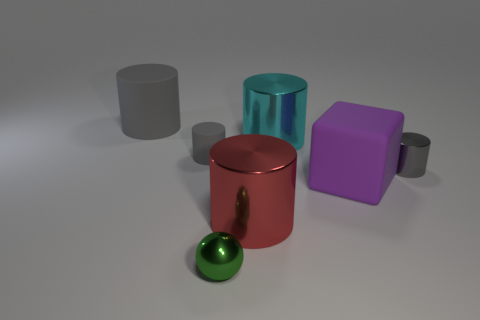Subtract all gray cylinders. How many were subtracted if there are1gray cylinders left? 2 Subtract all small matte cylinders. How many cylinders are left? 4 Subtract all gray cylinders. How many cylinders are left? 2 Add 7 red rubber objects. How many red rubber objects exist? 7 Add 1 tiny blue matte cylinders. How many objects exist? 8 Subtract 1 red cylinders. How many objects are left? 6 Subtract all cylinders. How many objects are left? 2 Subtract 1 cylinders. How many cylinders are left? 4 Subtract all purple cylinders. Subtract all brown spheres. How many cylinders are left? 5 Subtract all green balls. How many gray cylinders are left? 3 